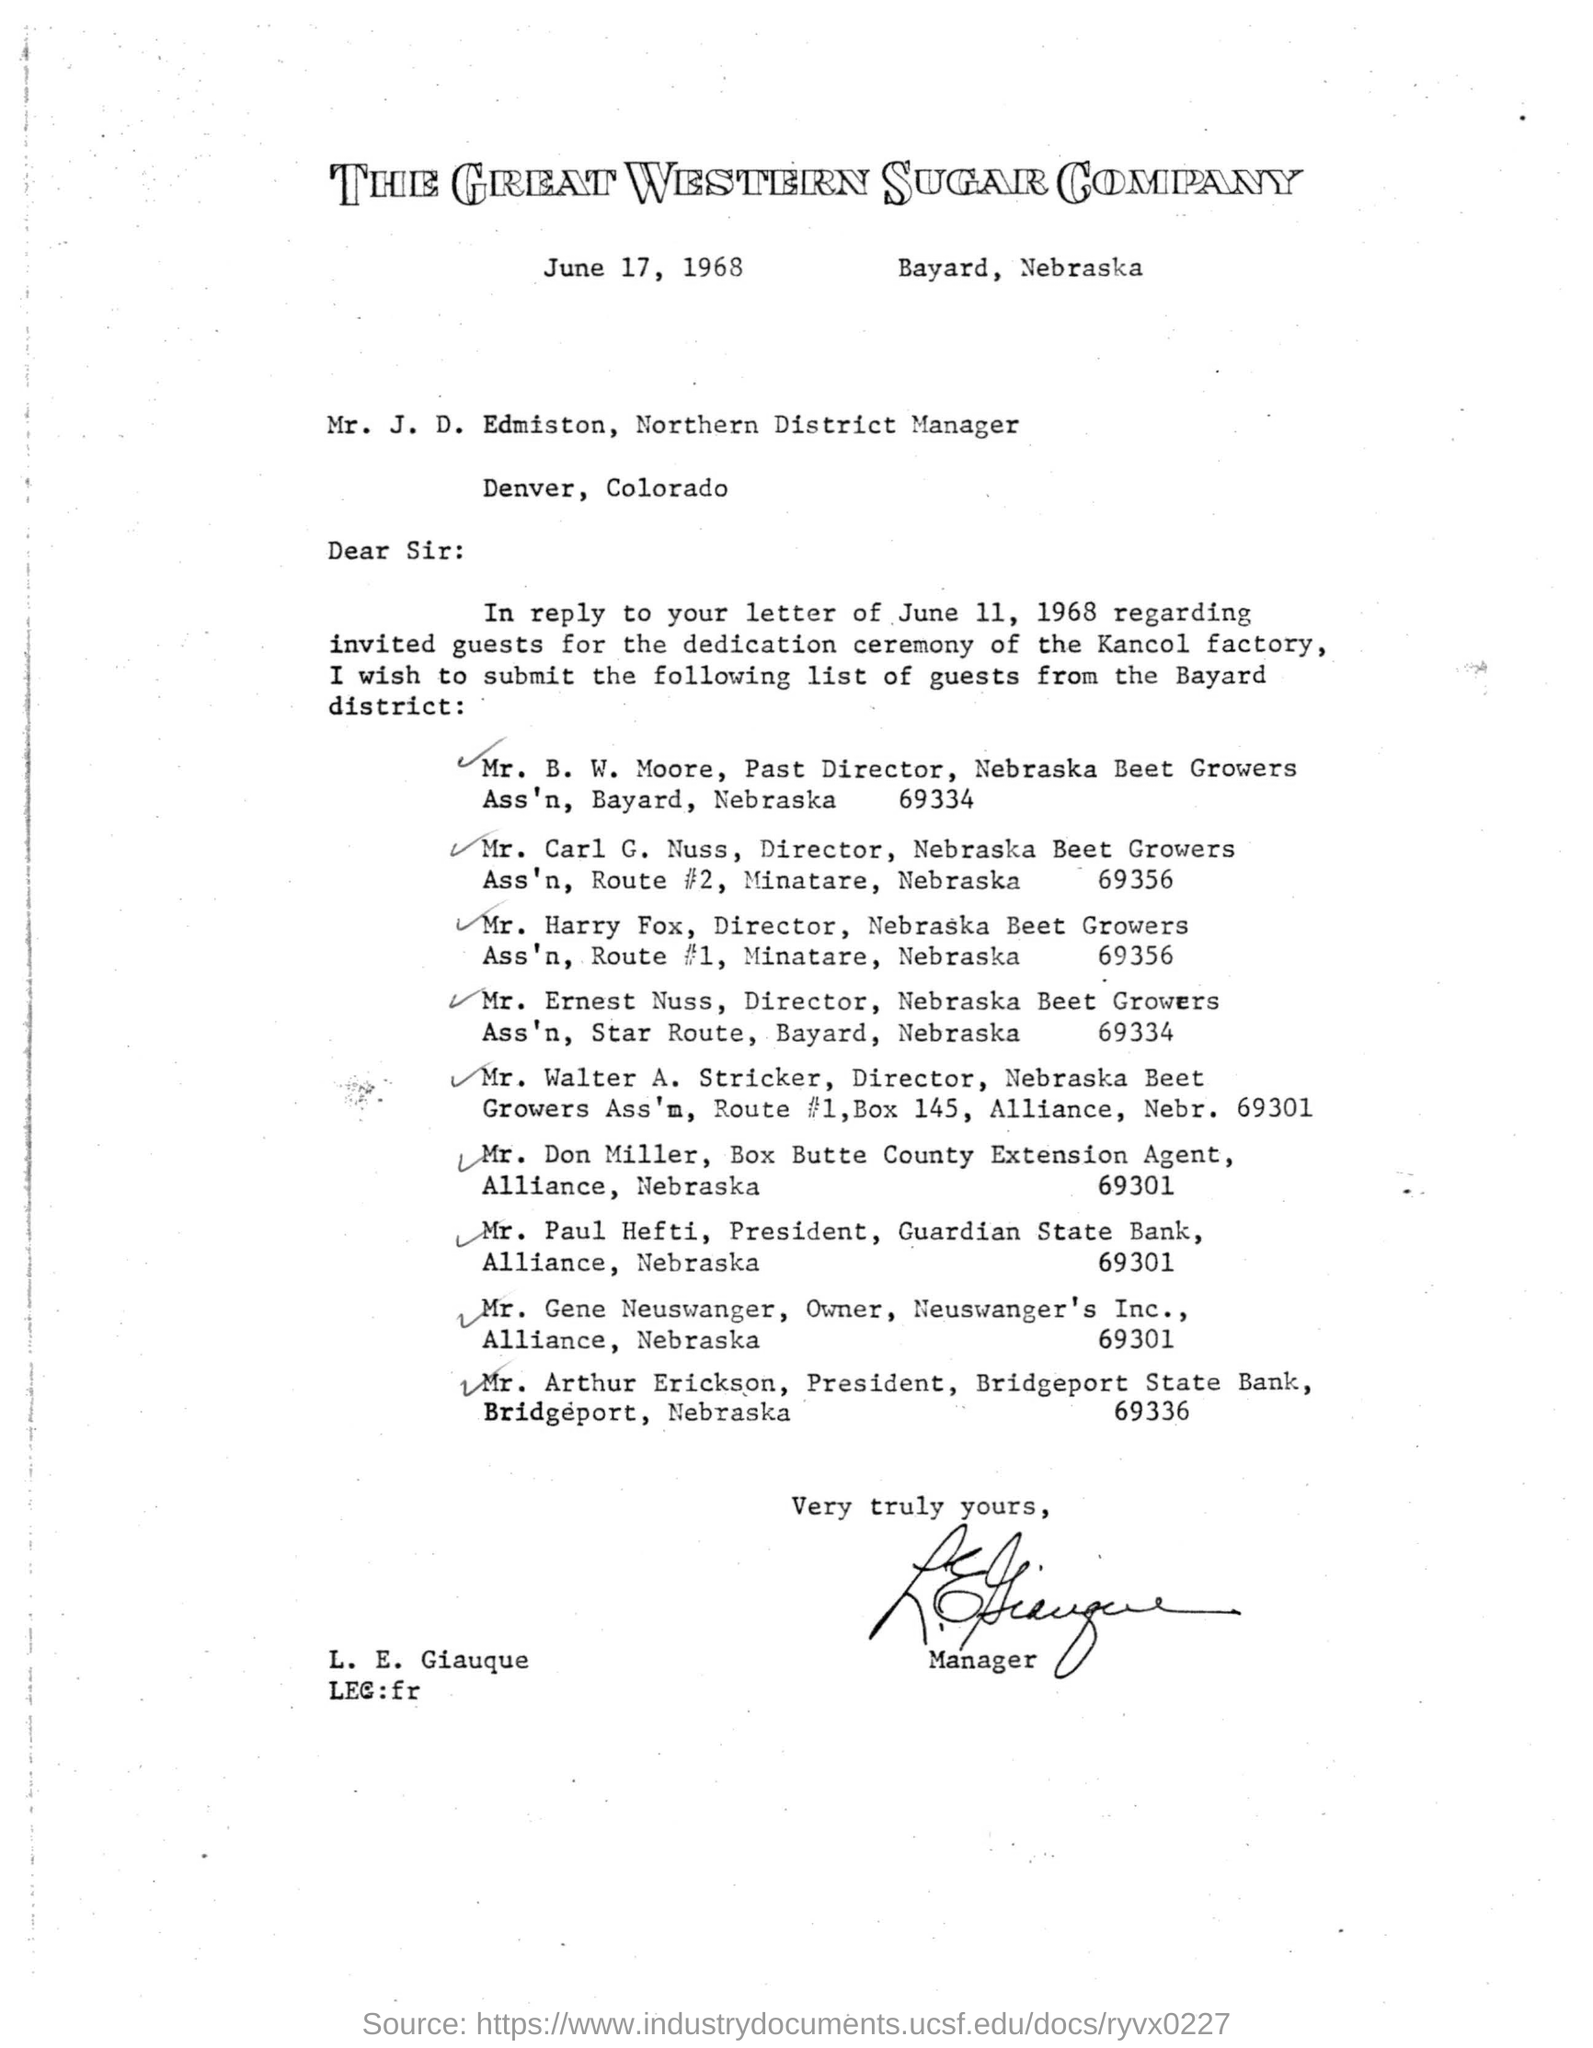What is the issued date of the letter?
Give a very brief answer. June 17, 1968. Who is the President of Bridgeport State Bank, Bridgeport, Nebraska?
Your answer should be very brief. Mr. Arthur Erickson. 